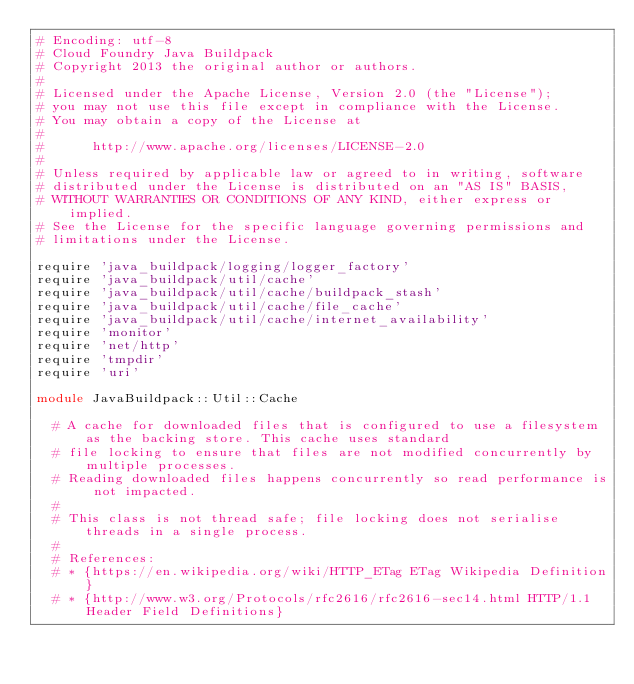<code> <loc_0><loc_0><loc_500><loc_500><_Ruby_># Encoding: utf-8
# Cloud Foundry Java Buildpack
# Copyright 2013 the original author or authors.
#
# Licensed under the Apache License, Version 2.0 (the "License");
# you may not use this file except in compliance with the License.
# You may obtain a copy of the License at
#
#      http://www.apache.org/licenses/LICENSE-2.0
#
# Unless required by applicable law or agreed to in writing, software
# distributed under the License is distributed on an "AS IS" BASIS,
# WITHOUT WARRANTIES OR CONDITIONS OF ANY KIND, either express or implied.
# See the License for the specific language governing permissions and
# limitations under the License.

require 'java_buildpack/logging/logger_factory'
require 'java_buildpack/util/cache'
require 'java_buildpack/util/cache/buildpack_stash'
require 'java_buildpack/util/cache/file_cache'
require 'java_buildpack/util/cache/internet_availability'
require 'monitor'
require 'net/http'
require 'tmpdir'
require 'uri'

module JavaBuildpack::Util::Cache

  # A cache for downloaded files that is configured to use a filesystem as the backing store. This cache uses standard
  # file locking to ensure that files are not modified concurrently by multiple processes.
  # Reading downloaded files happens concurrently so read performance is not impacted.
  #
  # This class is not thread safe; file locking does not serialise threads in a single process.
  #
  # References:
  # * {https://en.wikipedia.org/wiki/HTTP_ETag ETag Wikipedia Definition}
  # * {http://www.w3.org/Protocols/rfc2616/rfc2616-sec14.html HTTP/1.1 Header Field Definitions}</code> 